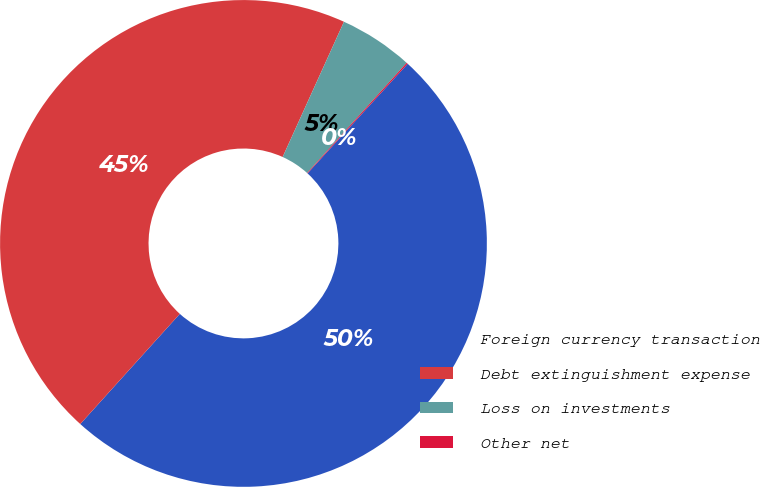Convert chart to OTSL. <chart><loc_0><loc_0><loc_500><loc_500><pie_chart><fcel>Foreign currency transaction<fcel>Debt extinguishment expense<fcel>Loss on investments<fcel>Other net<nl><fcel>49.91%<fcel>45.08%<fcel>4.92%<fcel>0.09%<nl></chart> 